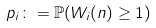<formula> <loc_0><loc_0><loc_500><loc_500>p _ { i } \colon = \mathbb { P } ( W _ { i } ( n ) \geq 1 )</formula> 